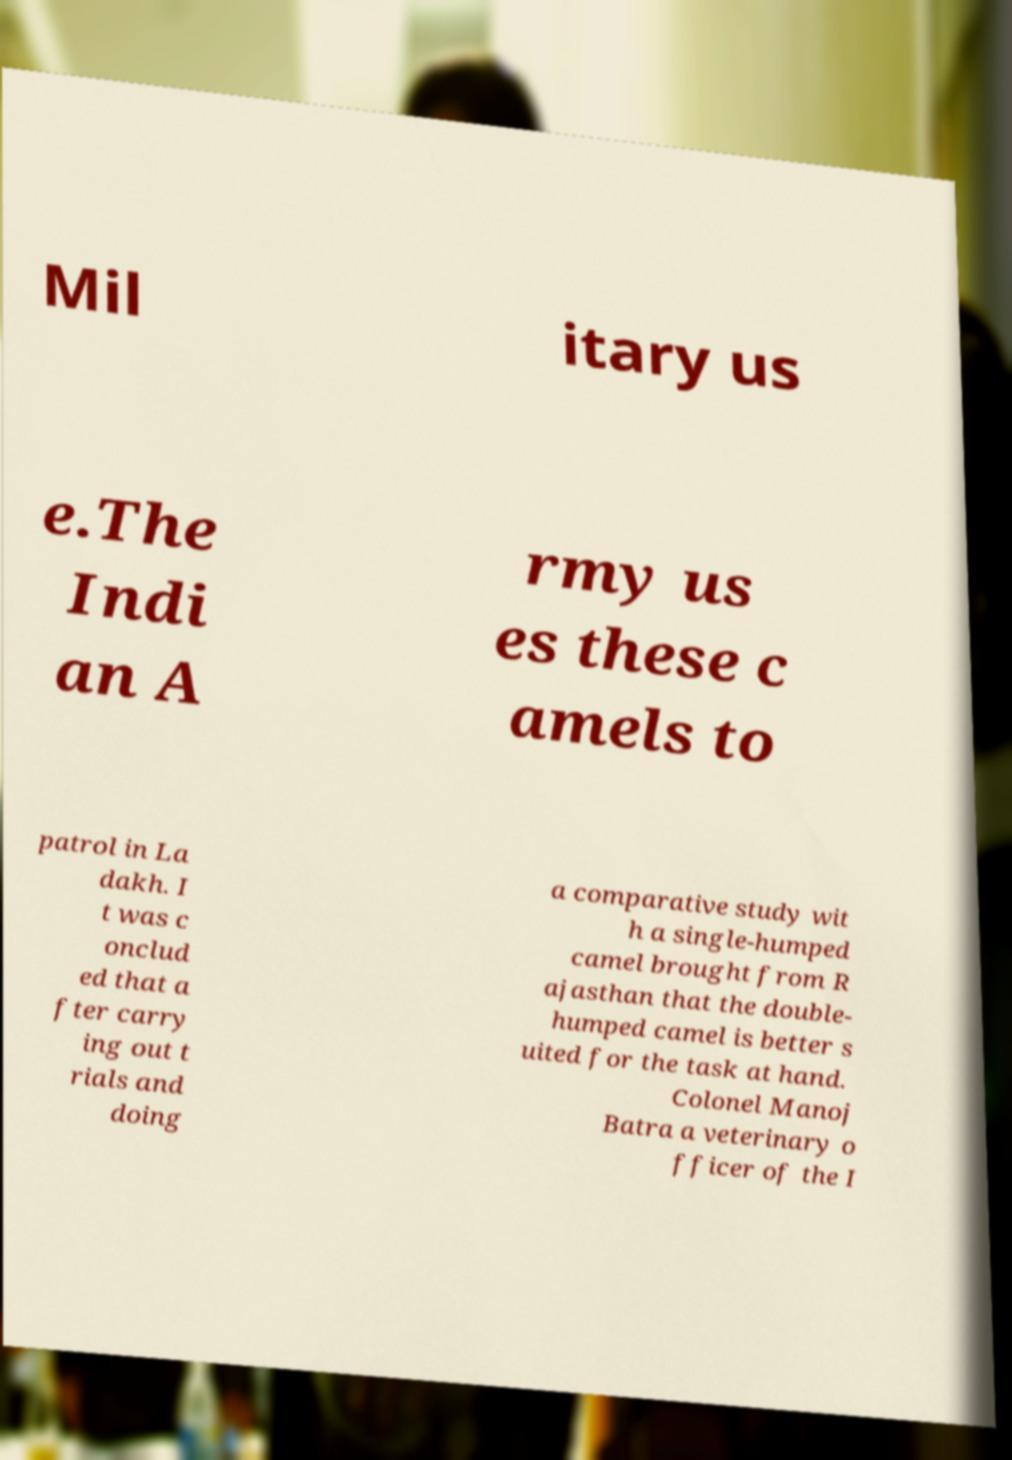Please identify and transcribe the text found in this image. Mil itary us e.The Indi an A rmy us es these c amels to patrol in La dakh. I t was c onclud ed that a fter carry ing out t rials and doing a comparative study wit h a single-humped camel brought from R ajasthan that the double- humped camel is better s uited for the task at hand. Colonel Manoj Batra a veterinary o fficer of the I 